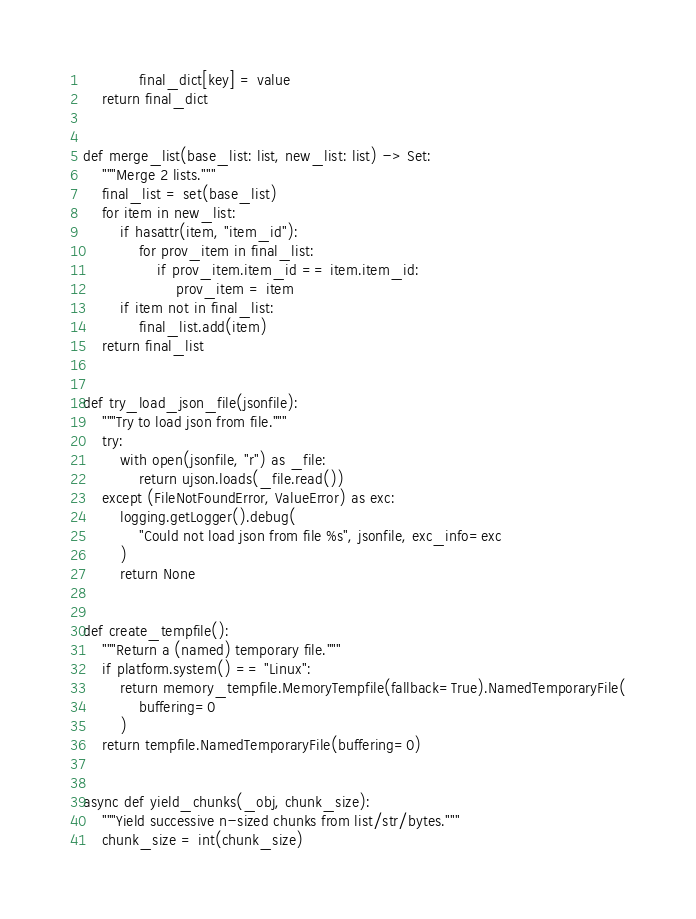Convert code to text. <code><loc_0><loc_0><loc_500><loc_500><_Python_>            final_dict[key] = value
    return final_dict


def merge_list(base_list: list, new_list: list) -> Set:
    """Merge 2 lists."""
    final_list = set(base_list)
    for item in new_list:
        if hasattr(item, "item_id"):
            for prov_item in final_list:
                if prov_item.item_id == item.item_id:
                    prov_item = item
        if item not in final_list:
            final_list.add(item)
    return final_list


def try_load_json_file(jsonfile):
    """Try to load json from file."""
    try:
        with open(jsonfile, "r") as _file:
            return ujson.loads(_file.read())
    except (FileNotFoundError, ValueError) as exc:
        logging.getLogger().debug(
            "Could not load json from file %s", jsonfile, exc_info=exc
        )
        return None


def create_tempfile():
    """Return a (named) temporary file."""
    if platform.system() == "Linux":
        return memory_tempfile.MemoryTempfile(fallback=True).NamedTemporaryFile(
            buffering=0
        )
    return tempfile.NamedTemporaryFile(buffering=0)


async def yield_chunks(_obj, chunk_size):
    """Yield successive n-sized chunks from list/str/bytes."""
    chunk_size = int(chunk_size)</code> 